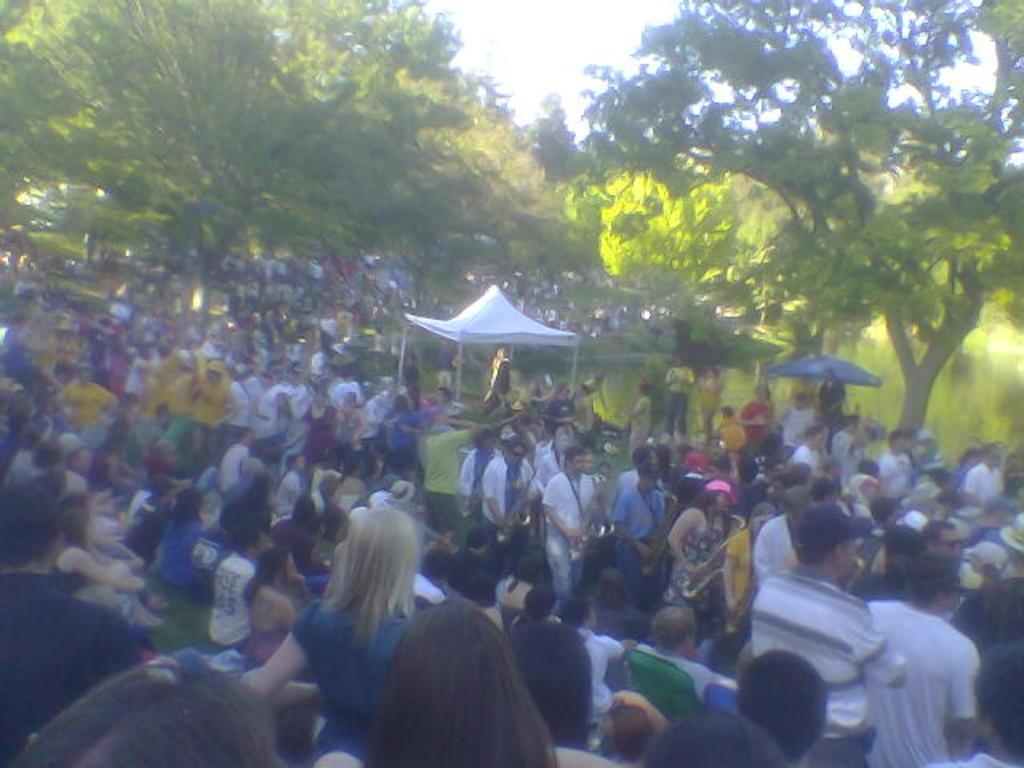How many people are in the image? The number of people in the image is not specified, but there are people present. What are some of the people doing in the image? Some people are holding objects in the image. What can be seen in the background of the image? There are trees and tents visible in the background of the image. What type of waves can be seen crashing on the shore in the image? There is no reference to a shore or waves in the image, so it is not possible to answer that question. 